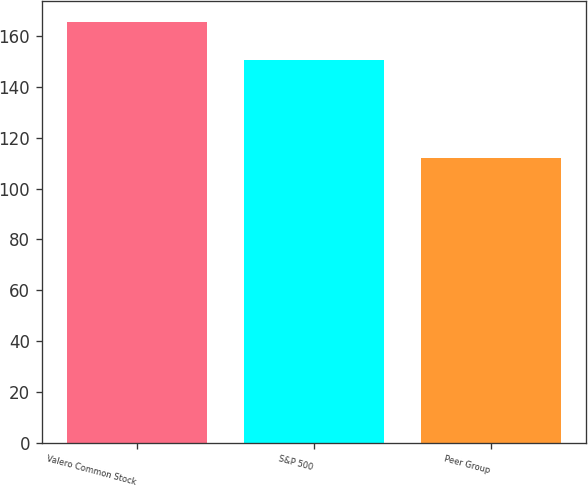<chart> <loc_0><loc_0><loc_500><loc_500><bar_chart><fcel>Valero Common Stock<fcel>S&P 500<fcel>Peer Group<nl><fcel>165.4<fcel>150.51<fcel>111.98<nl></chart> 